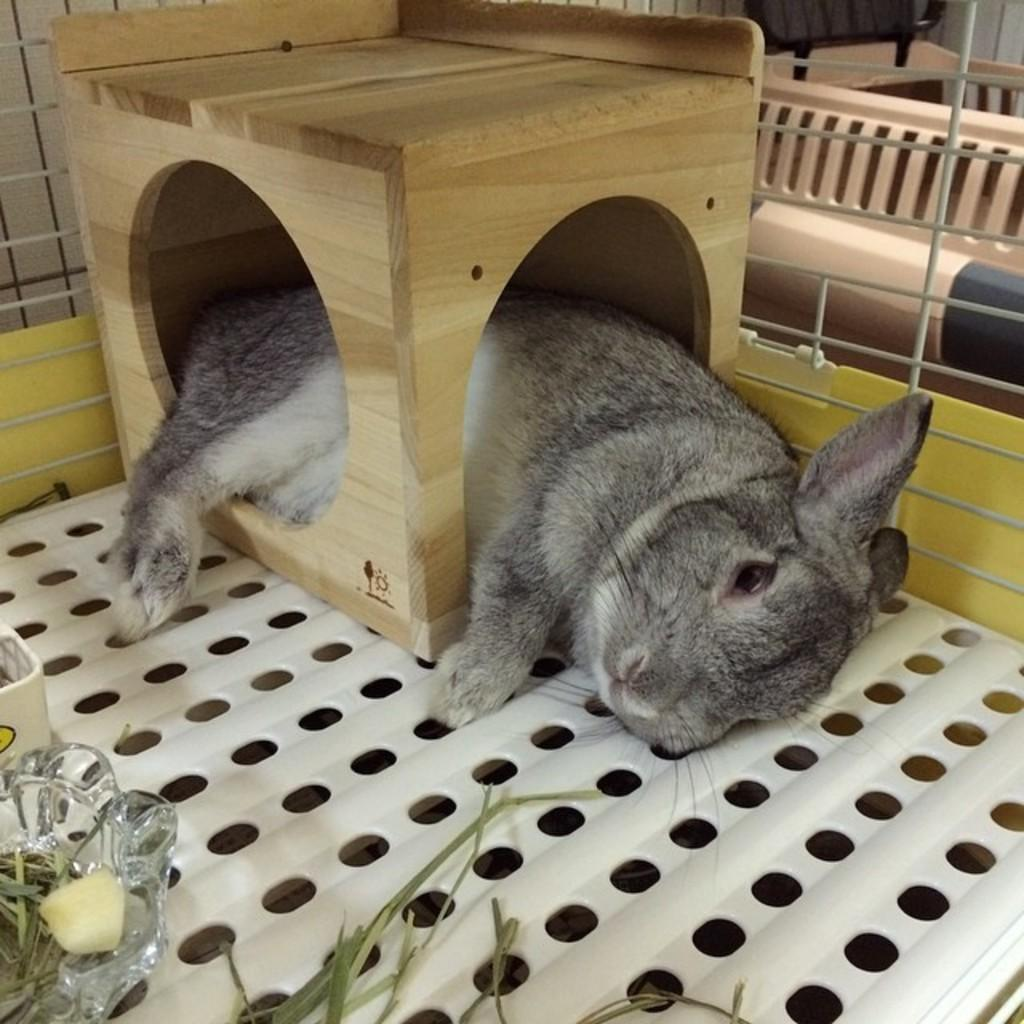What animal can be seen in the image? There is a rabbit in the image. What is the rabbit doing in the image? The rabbit is sleeping in a pet bed. What type of vegetation is visible in the image? There is grass visible in the image. What type of objects are made of glass in the image? There are glass objects in the image. Can you describe the object on the right side of the image? Unfortunately, the facts provided do not specify the nature of the object on the right side of the image. What type of legal advice is the rabbit seeking in the image? There is no indication in the image that the rabbit is seeking legal advice or interacting with a lawyer. 